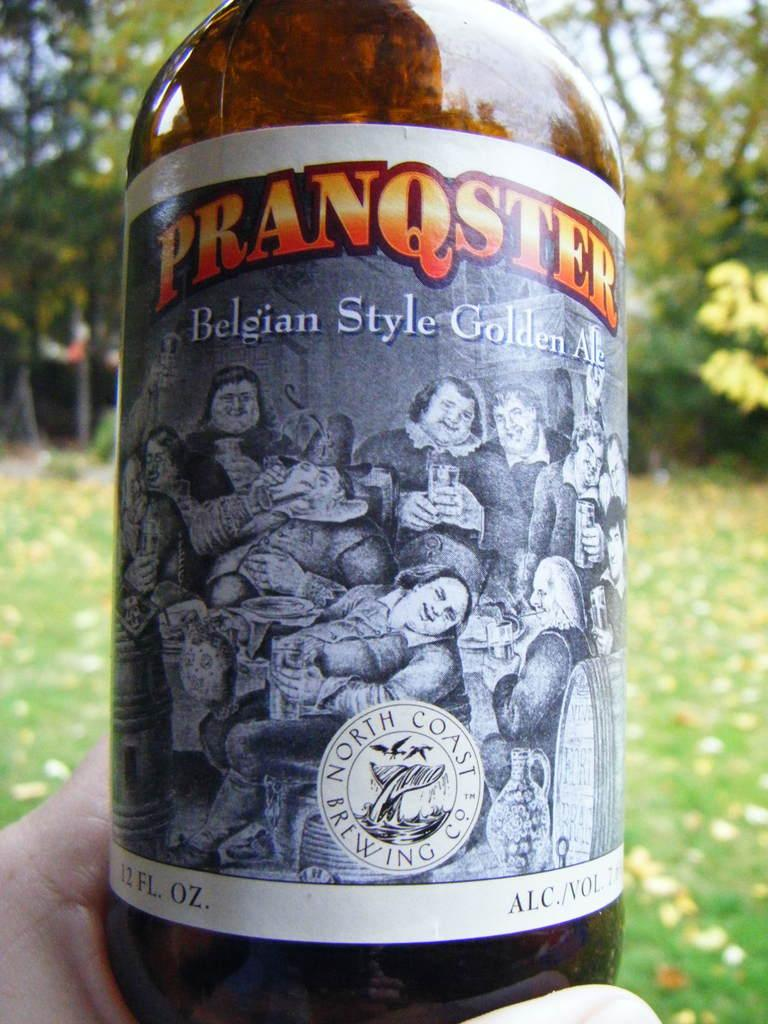Provide a one-sentence caption for the provided image. A bottle with quirky picture filled with golden ale. 